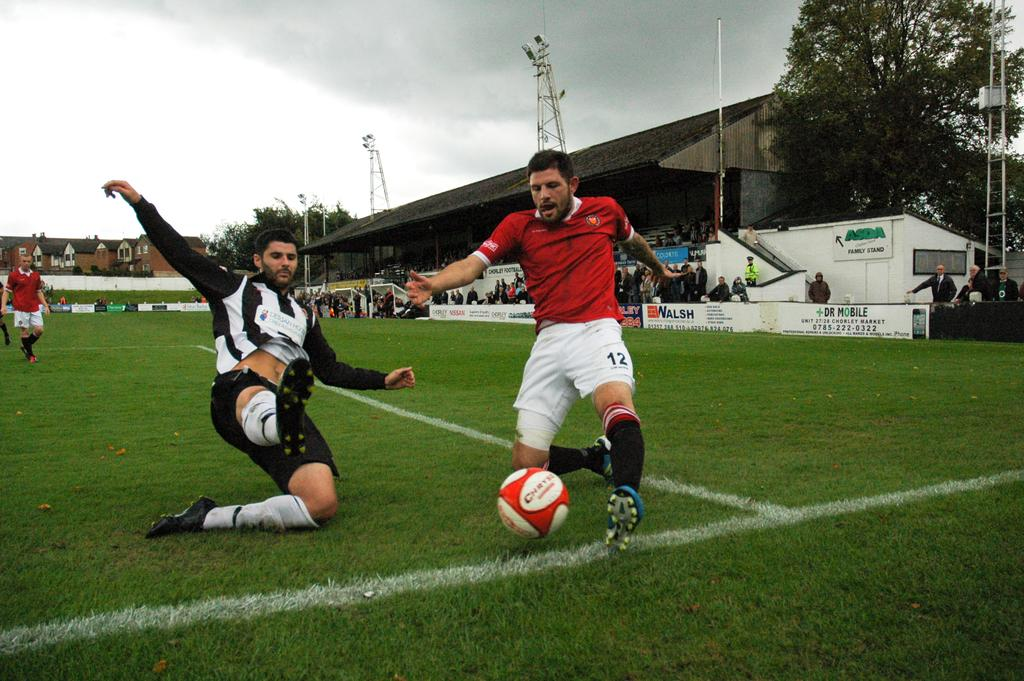<image>
Provide a brief description of the given image. a soccer player with shorts that have the number 12 on them 